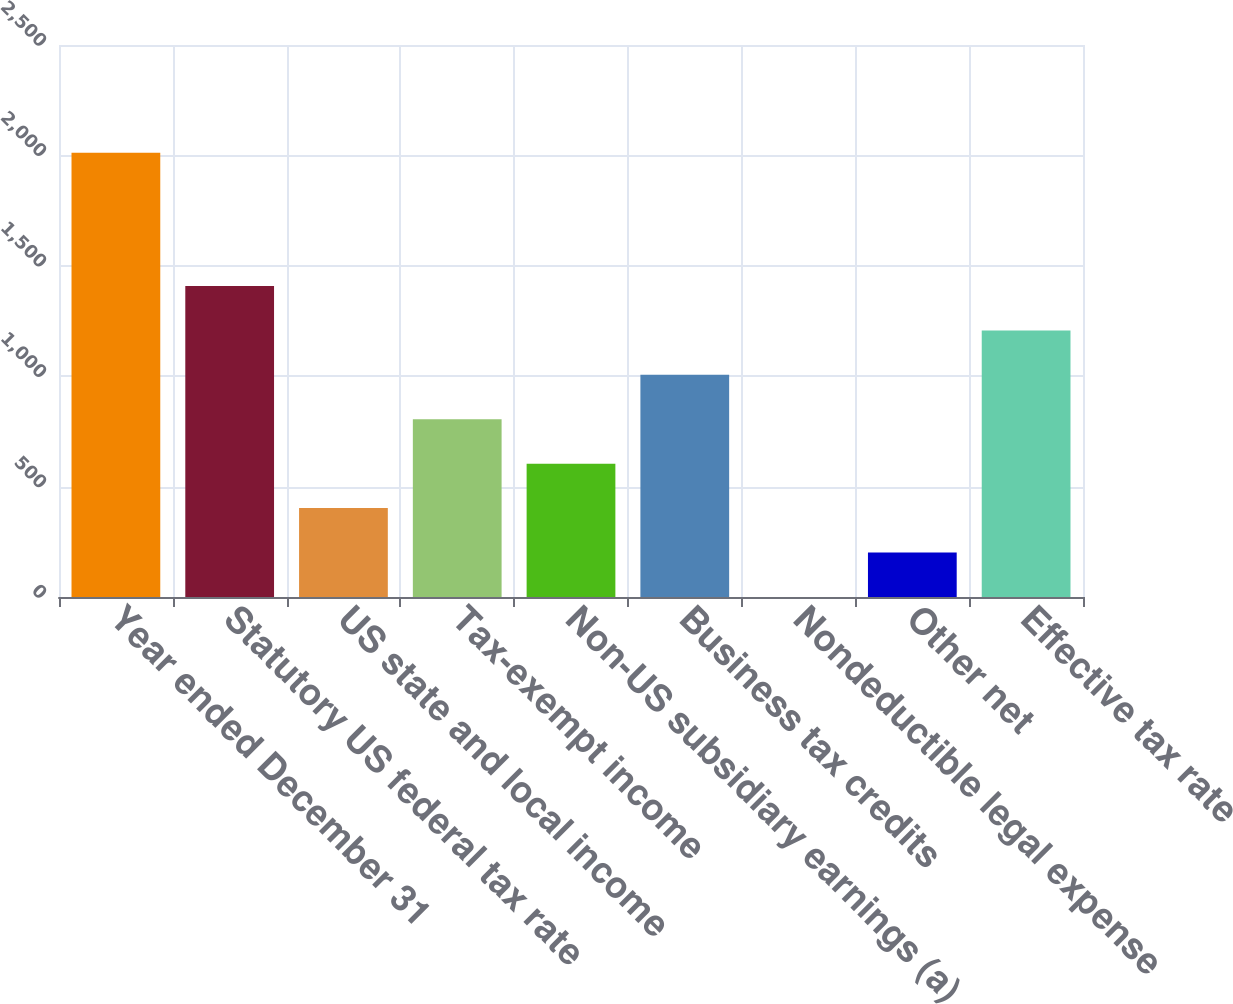Convert chart to OTSL. <chart><loc_0><loc_0><loc_500><loc_500><bar_chart><fcel>Year ended December 31<fcel>Statutory US federal tax rate<fcel>US state and local income<fcel>Tax-exempt income<fcel>Non-US subsidiary earnings (a)<fcel>Business tax credits<fcel>Nondeductible legal expense<fcel>Other net<fcel>Effective tax rate<nl><fcel>2012<fcel>1408.46<fcel>402.56<fcel>804.92<fcel>603.74<fcel>1006.1<fcel>0.2<fcel>201.38<fcel>1207.28<nl></chart> 